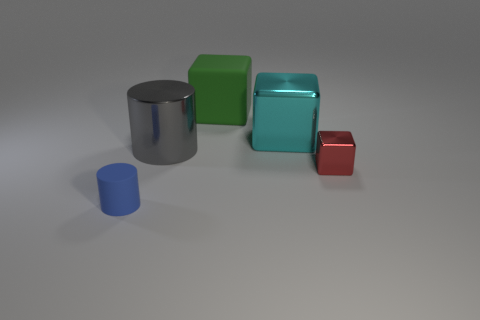Subtract all shiny blocks. How many blocks are left? 1 Add 3 big gray metal objects. How many objects exist? 8 Subtract all red cubes. How many cubes are left? 2 Subtract all cylinders. How many objects are left? 3 Subtract all gray cubes. Subtract all green balls. How many cubes are left? 3 Subtract all tiny yellow matte cylinders. Subtract all tiny red shiny objects. How many objects are left? 4 Add 3 large cyan shiny things. How many large cyan shiny things are left? 4 Add 4 big brown objects. How many big brown objects exist? 4 Subtract 1 gray cylinders. How many objects are left? 4 